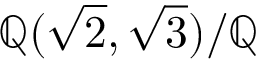Convert formula to latex. <formula><loc_0><loc_0><loc_500><loc_500>\mathbb { Q } ( { \sqrt { 2 } } , { \sqrt { 3 } } ) / \mathbb { Q }</formula> 